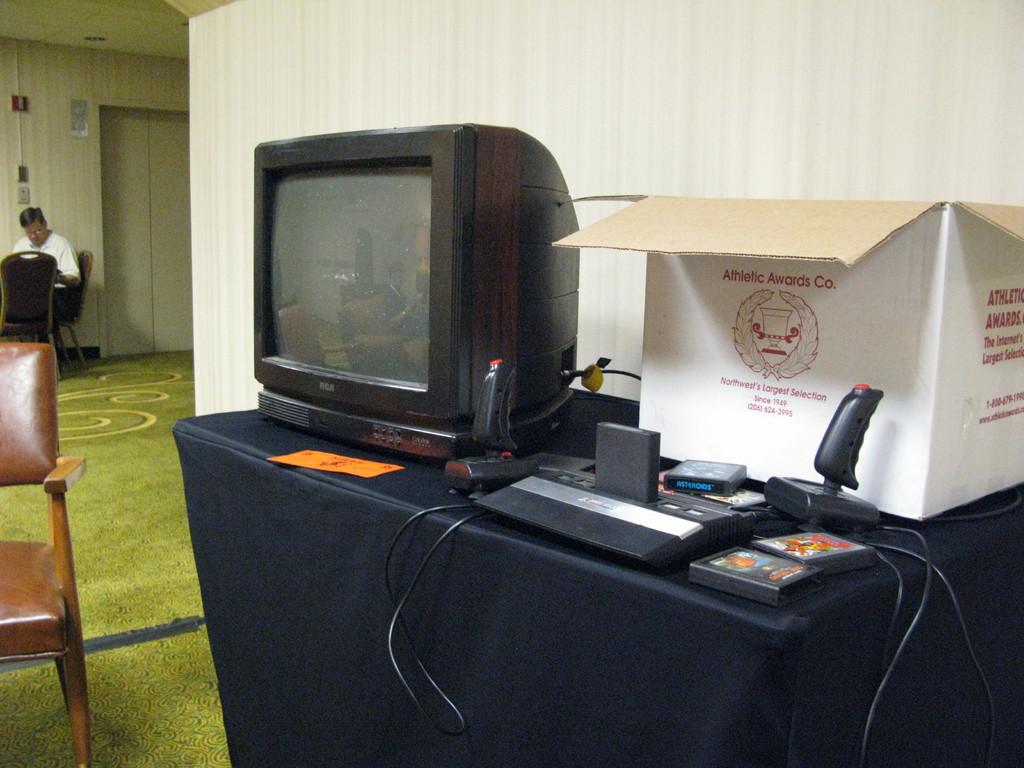What company name is printed on the front of the white box?
Offer a terse response. Athletic awards co. Is this the northwest's largest selection, mentioned on the box?
Offer a terse response. Yes. 